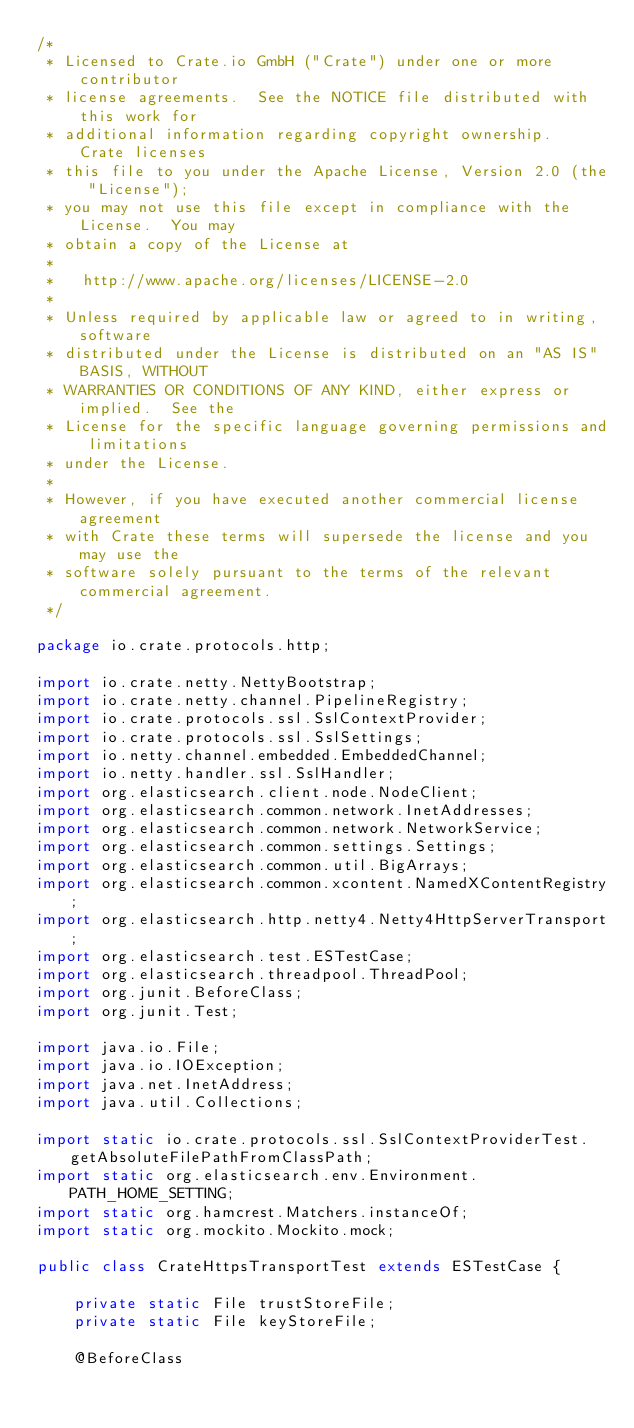Convert code to text. <code><loc_0><loc_0><loc_500><loc_500><_Java_>/*
 * Licensed to Crate.io GmbH ("Crate") under one or more contributor
 * license agreements.  See the NOTICE file distributed with this work for
 * additional information regarding copyright ownership.  Crate licenses
 * this file to you under the Apache License, Version 2.0 (the "License");
 * you may not use this file except in compliance with the License.  You may
 * obtain a copy of the License at
 *
 *   http://www.apache.org/licenses/LICENSE-2.0
 *
 * Unless required by applicable law or agreed to in writing, software
 * distributed under the License is distributed on an "AS IS" BASIS, WITHOUT
 * WARRANTIES OR CONDITIONS OF ANY KIND, either express or implied.  See the
 * License for the specific language governing permissions and limitations
 * under the License.
 *
 * However, if you have executed another commercial license agreement
 * with Crate these terms will supersede the license and you may use the
 * software solely pursuant to the terms of the relevant commercial agreement.
 */

package io.crate.protocols.http;

import io.crate.netty.NettyBootstrap;
import io.crate.netty.channel.PipelineRegistry;
import io.crate.protocols.ssl.SslContextProvider;
import io.crate.protocols.ssl.SslSettings;
import io.netty.channel.embedded.EmbeddedChannel;
import io.netty.handler.ssl.SslHandler;
import org.elasticsearch.client.node.NodeClient;
import org.elasticsearch.common.network.InetAddresses;
import org.elasticsearch.common.network.NetworkService;
import org.elasticsearch.common.settings.Settings;
import org.elasticsearch.common.util.BigArrays;
import org.elasticsearch.common.xcontent.NamedXContentRegistry;
import org.elasticsearch.http.netty4.Netty4HttpServerTransport;
import org.elasticsearch.test.ESTestCase;
import org.elasticsearch.threadpool.ThreadPool;
import org.junit.BeforeClass;
import org.junit.Test;

import java.io.File;
import java.io.IOException;
import java.net.InetAddress;
import java.util.Collections;

import static io.crate.protocols.ssl.SslContextProviderTest.getAbsoluteFilePathFromClassPath;
import static org.elasticsearch.env.Environment.PATH_HOME_SETTING;
import static org.hamcrest.Matchers.instanceOf;
import static org.mockito.Mockito.mock;

public class CrateHttpsTransportTest extends ESTestCase {

    private static File trustStoreFile;
    private static File keyStoreFile;

    @BeforeClass</code> 